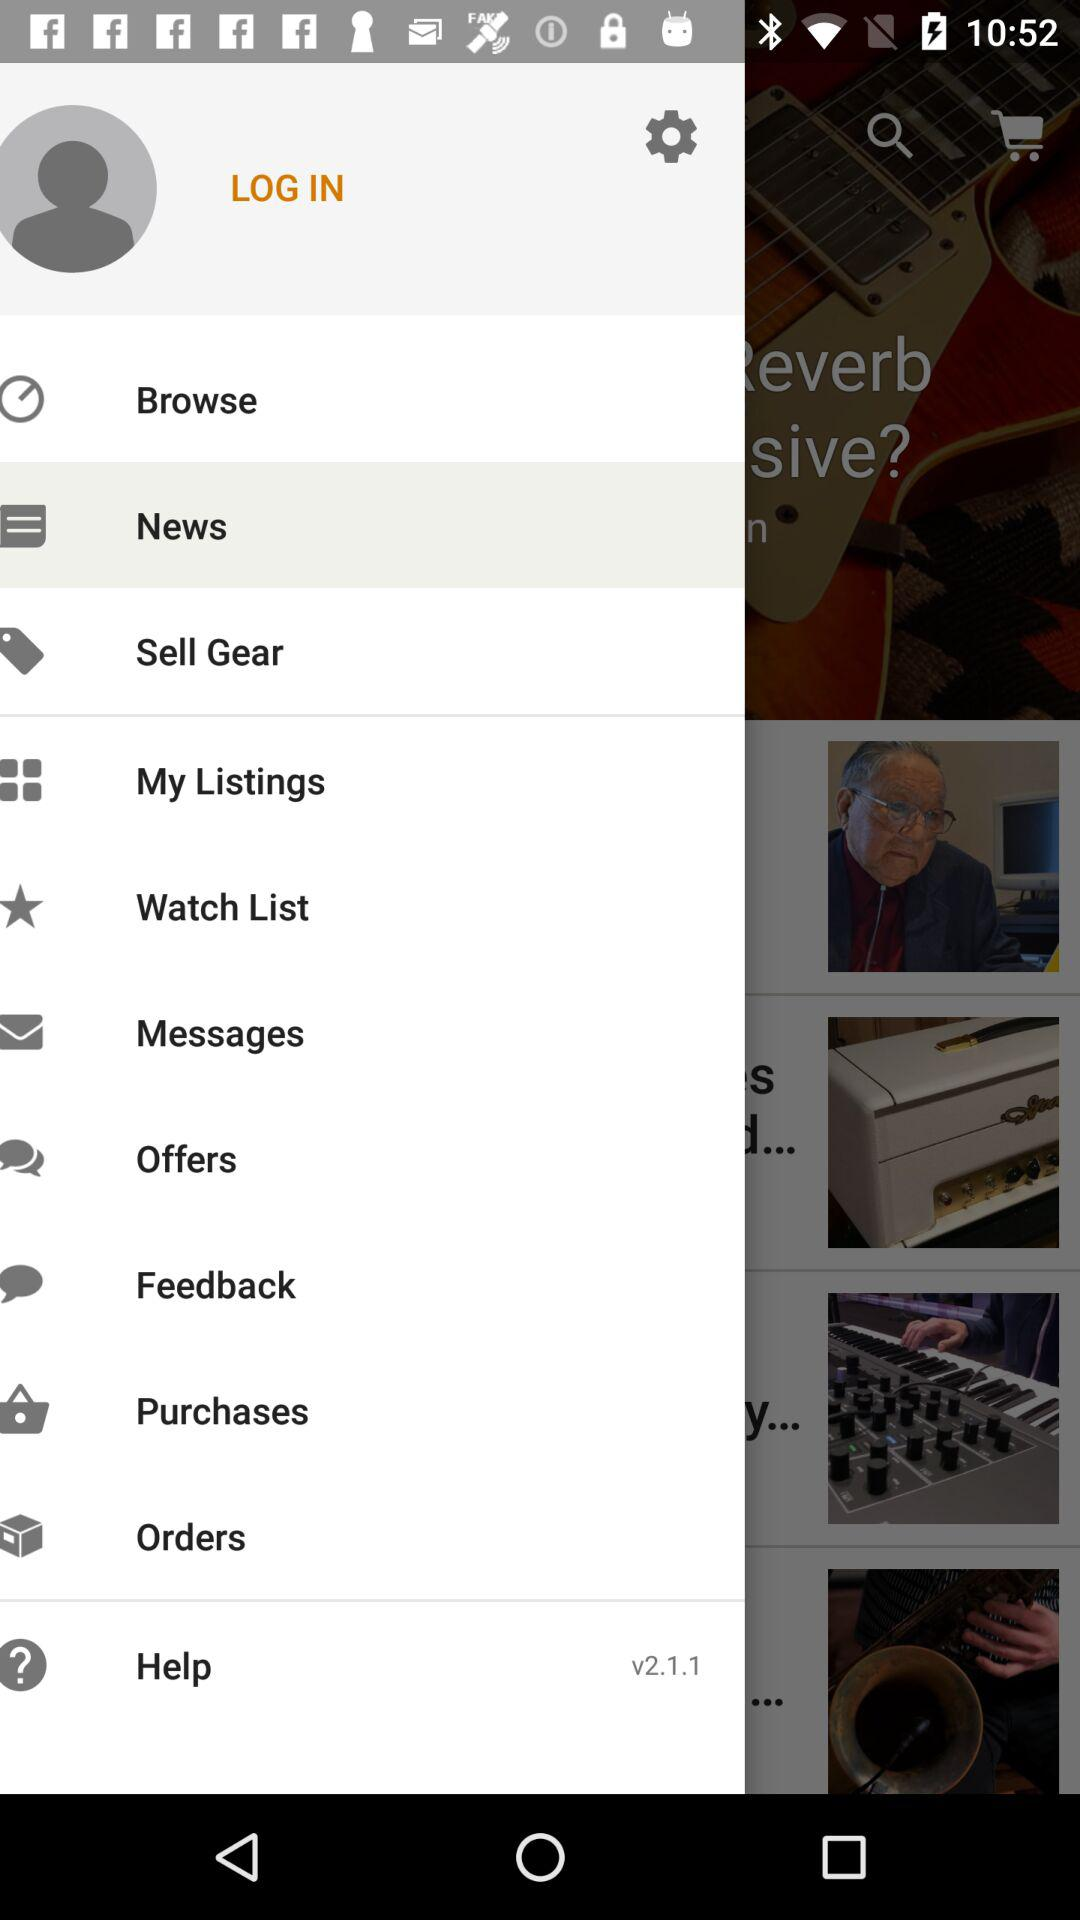What is the version? The version is v2.1.1. 